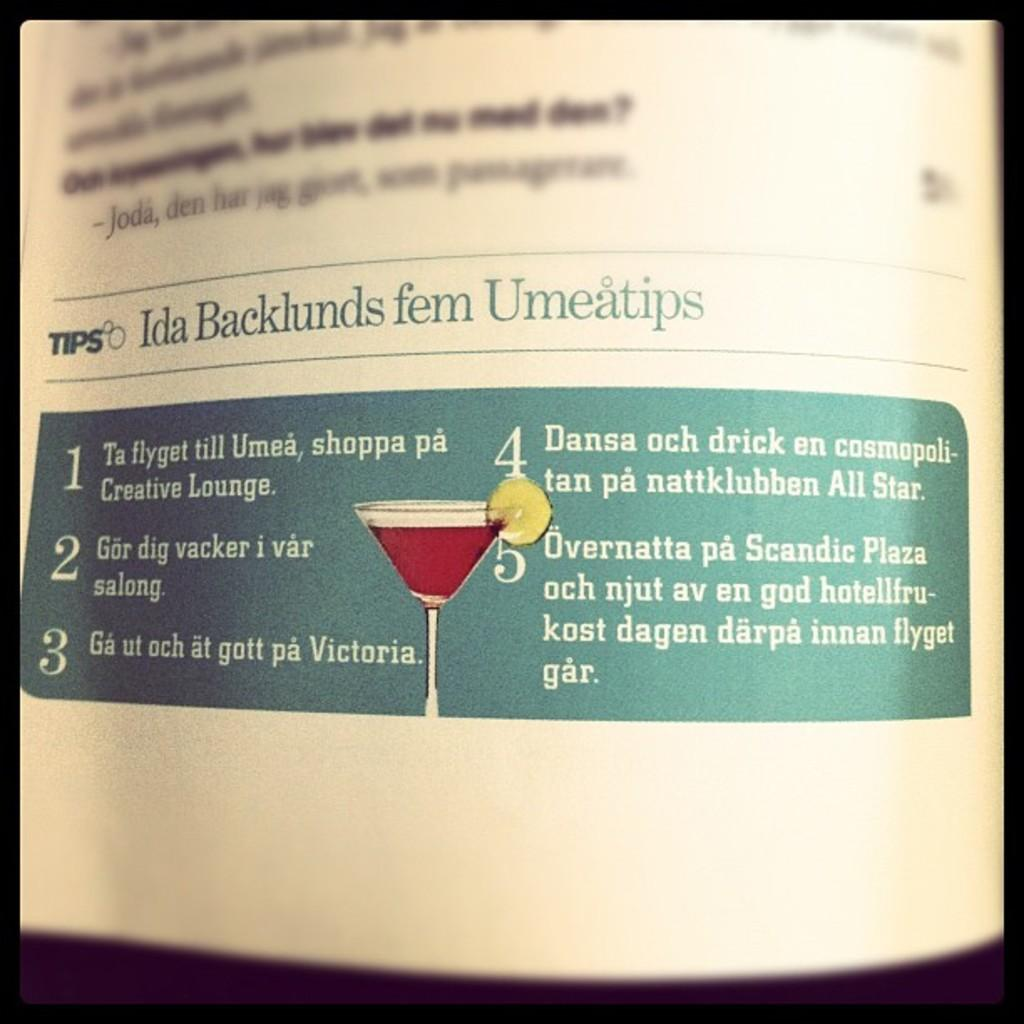<image>
Relay a brief, clear account of the picture shown. A paper has a picture of a martini in the section labeled "tips". 